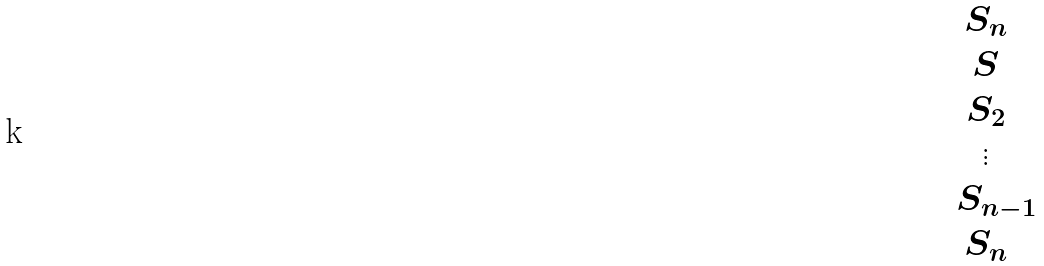Convert formula to latex. <formula><loc_0><loc_0><loc_500><loc_500>\begin{matrix} S _ { n } \\ S \\ S _ { 2 } \\ \vdots \\ \ \ S _ { n - 1 } \\ S _ { n } \end{matrix}</formula> 